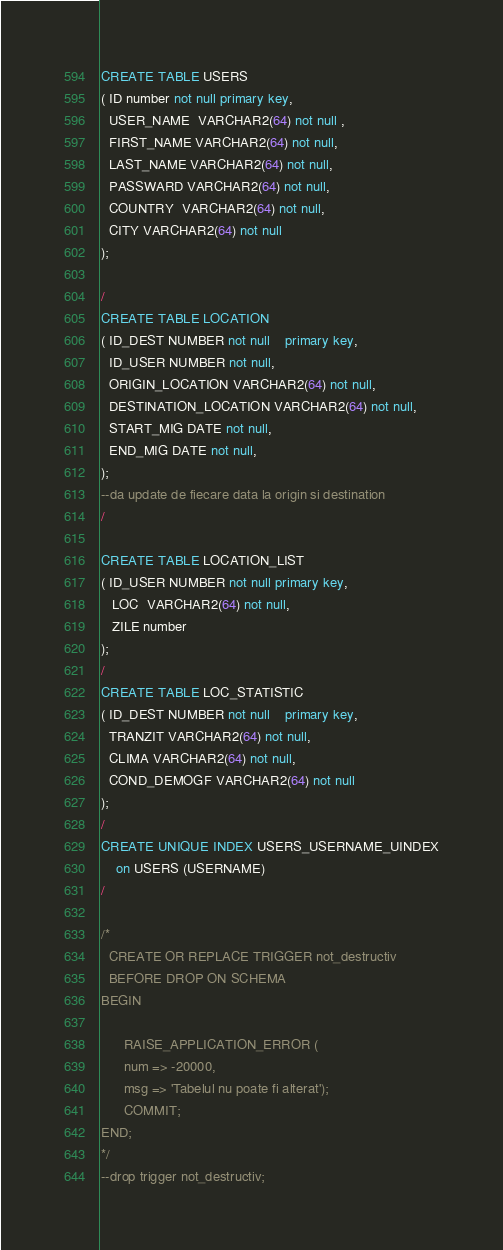<code> <loc_0><loc_0><loc_500><loc_500><_SQL_>CREATE TABLE USERS
( ID number not null primary key,
  USER_NAME  VARCHAR2(64) not null ,
  FIRST_NAME VARCHAR2(64) not null,
  LAST_NAME VARCHAR2(64) not null,
  PASSWARD VARCHAR2(64) not null,
  COUNTRY  VARCHAR2(64) not null,
  CITY VARCHAR2(64) not null
);

/
CREATE TABLE LOCATION
( ID_DEST NUMBER not null	primary key,
  ID_USER NUMBER not null,
  ORIGIN_LOCATION VARCHAR2(64) not null,
  DESTINATION_LOCATION VARCHAR2(64) not null,
  START_MIG DATE not null,
  END_MIG DATE not null,
);
--da update de fiecare data la origin si destination
/

CREATE TABLE LOCATION_LIST
( ID_USER NUMBER not null primary key,
   LOC  VARCHAR2(64) not null,
   ZILE number
);
/
CREATE TABLE LOC_STATISTIC
( ID_DEST NUMBER not null	primary key,
  TRANZIT VARCHAR2(64) not null,
  CLIMA VARCHAR2(64) not null,
  COND_DEMOGF VARCHAR2(64) not null
);
/
CREATE UNIQUE INDEX USERS_USERNAME_UINDEX
	on USERS (USERNAME)
/  

/*
  CREATE OR REPLACE TRIGGER not_destructiv
  BEFORE DROP ON SCHEMA
BEGIN
     
      RAISE_APPLICATION_ERROR (
      num => -20000,
      msg => 'Tabelul nu poate fi alterat');
      COMMIT;
END;   
*/
--drop trigger not_destructiv;

</code> 